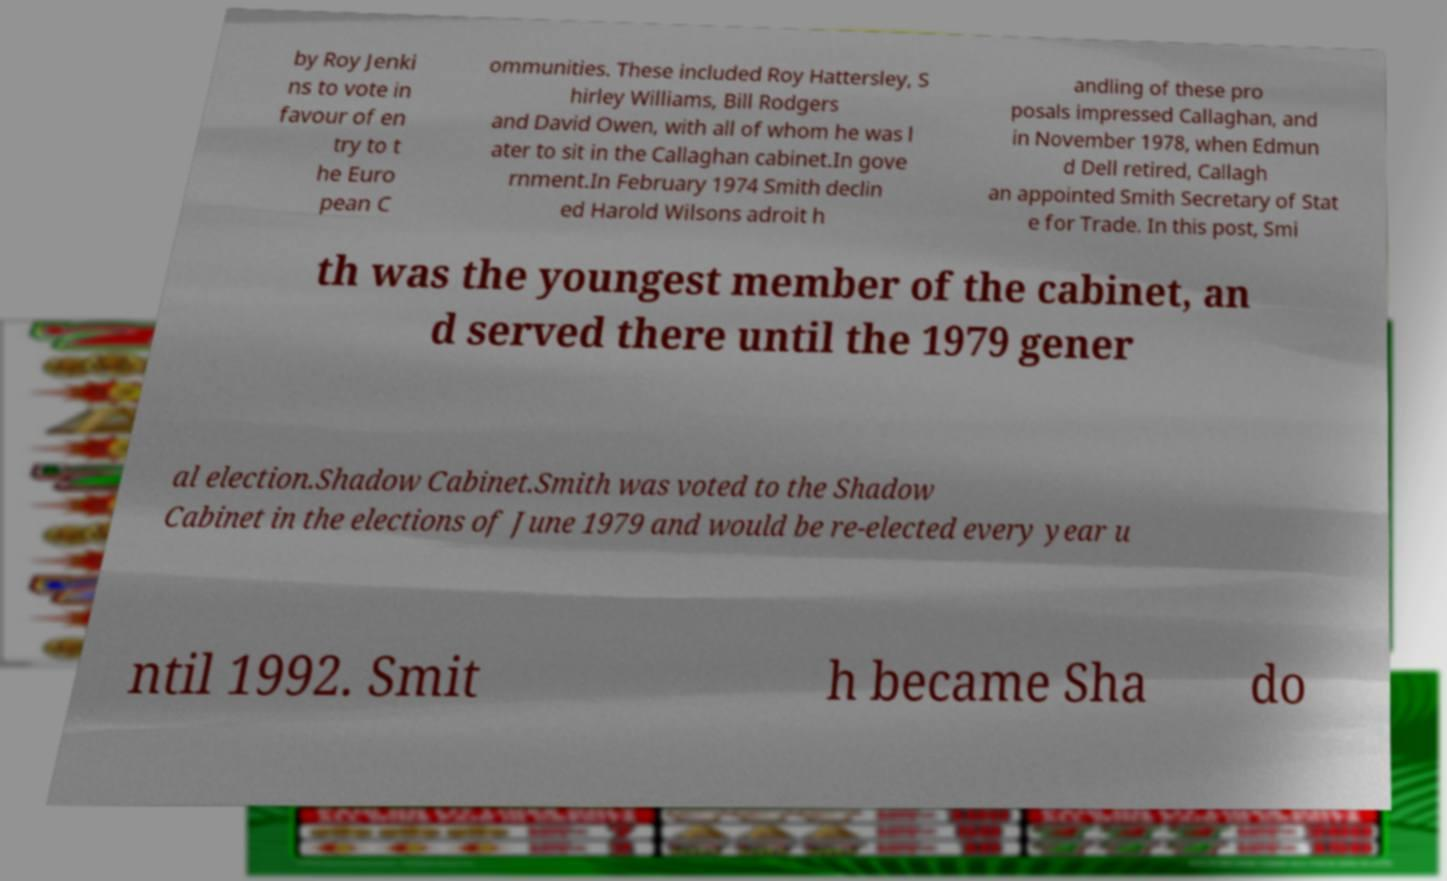Could you extract and type out the text from this image? by Roy Jenki ns to vote in favour of en try to t he Euro pean C ommunities. These included Roy Hattersley, S hirley Williams, Bill Rodgers and David Owen, with all of whom he was l ater to sit in the Callaghan cabinet.In gove rnment.In February 1974 Smith declin ed Harold Wilsons adroit h andling of these pro posals impressed Callaghan, and in November 1978, when Edmun d Dell retired, Callagh an appointed Smith Secretary of Stat e for Trade. In this post, Smi th was the youngest member of the cabinet, an d served there until the 1979 gener al election.Shadow Cabinet.Smith was voted to the Shadow Cabinet in the elections of June 1979 and would be re-elected every year u ntil 1992. Smit h became Sha do 